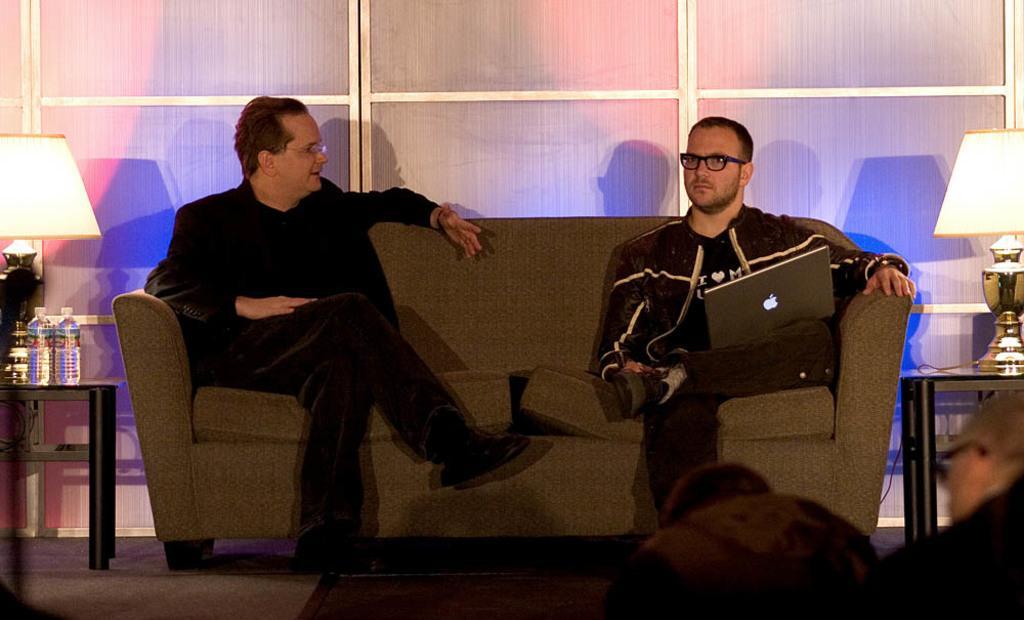Describe this image in one or two sentences. In this image, there are two person sitting on the sofa and talking. At the bottom two person half visible. On the left, a table is visible on which two bottles are there and a lamp is kept on both side. In the background windows are visible of glass. This image is taken inside a room. 